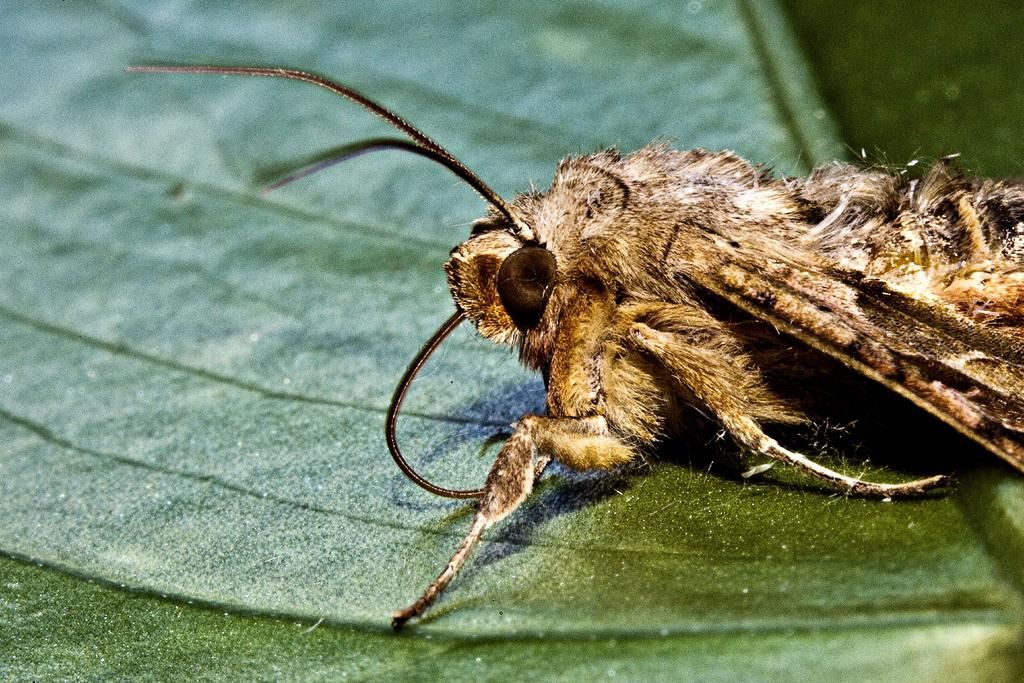What is present on the leaf in the image? There is an insect on the leaf in the image. Can you describe the insect's location on the leaf? The insect is on the leaf in the image. What type of mitten is the insect wearing in the image? There is no mitten present in the image, and insects do not wear clothing. 